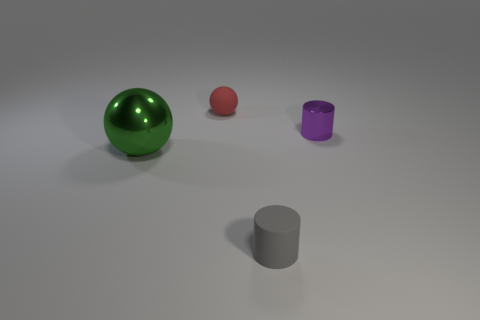There is a large green thing that is the same shape as the red thing; what is its material?
Offer a very short reply. Metal. There is a gray object right of the rubber thing that is behind the small object that is right of the gray matte cylinder; what is its material?
Offer a terse response. Rubber. There is a gray thing that is made of the same material as the tiny ball; what size is it?
Your answer should be compact. Small. Is there anything else that is the same color as the tiny shiny object?
Make the answer very short. No. Is the color of the tiny thing behind the purple cylinder the same as the object that is on the right side of the small gray cylinder?
Provide a succinct answer. No. What is the color of the tiny cylinder that is behind the small gray matte cylinder?
Offer a terse response. Purple. Is the size of the rubber thing that is left of the gray cylinder the same as the small purple cylinder?
Ensure brevity in your answer.  Yes. Are there fewer small purple shiny objects than large blue rubber blocks?
Offer a terse response. No. What number of gray cylinders are to the right of the big sphere?
Make the answer very short. 1. Does the large green object have the same shape as the tiny red object?
Provide a succinct answer. Yes. 